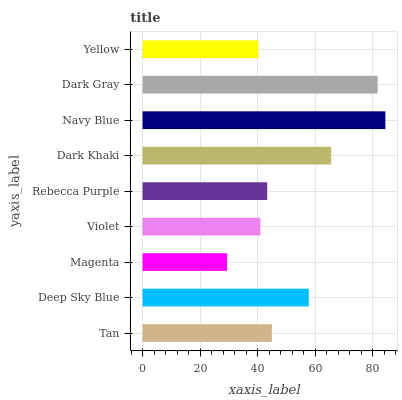Is Magenta the minimum?
Answer yes or no. Yes. Is Navy Blue the maximum?
Answer yes or no. Yes. Is Deep Sky Blue the minimum?
Answer yes or no. No. Is Deep Sky Blue the maximum?
Answer yes or no. No. Is Deep Sky Blue greater than Tan?
Answer yes or no. Yes. Is Tan less than Deep Sky Blue?
Answer yes or no. Yes. Is Tan greater than Deep Sky Blue?
Answer yes or no. No. Is Deep Sky Blue less than Tan?
Answer yes or no. No. Is Tan the high median?
Answer yes or no. Yes. Is Tan the low median?
Answer yes or no. Yes. Is Dark Gray the high median?
Answer yes or no. No. Is Magenta the low median?
Answer yes or no. No. 